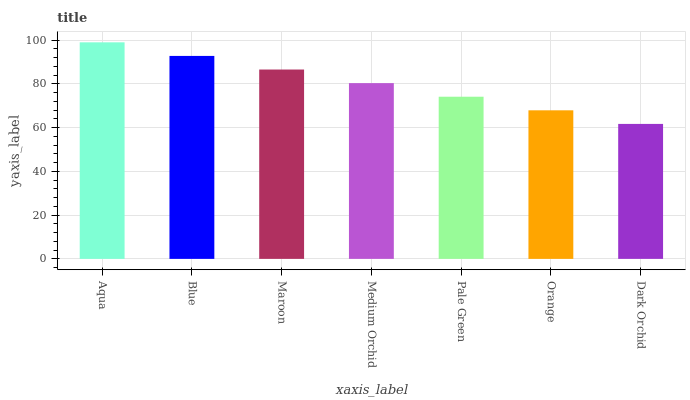Is Dark Orchid the minimum?
Answer yes or no. Yes. Is Aqua the maximum?
Answer yes or no. Yes. Is Blue the minimum?
Answer yes or no. No. Is Blue the maximum?
Answer yes or no. No. Is Aqua greater than Blue?
Answer yes or no. Yes. Is Blue less than Aqua?
Answer yes or no. Yes. Is Blue greater than Aqua?
Answer yes or no. No. Is Aqua less than Blue?
Answer yes or no. No. Is Medium Orchid the high median?
Answer yes or no. Yes. Is Medium Orchid the low median?
Answer yes or no. Yes. Is Dark Orchid the high median?
Answer yes or no. No. Is Aqua the low median?
Answer yes or no. No. 